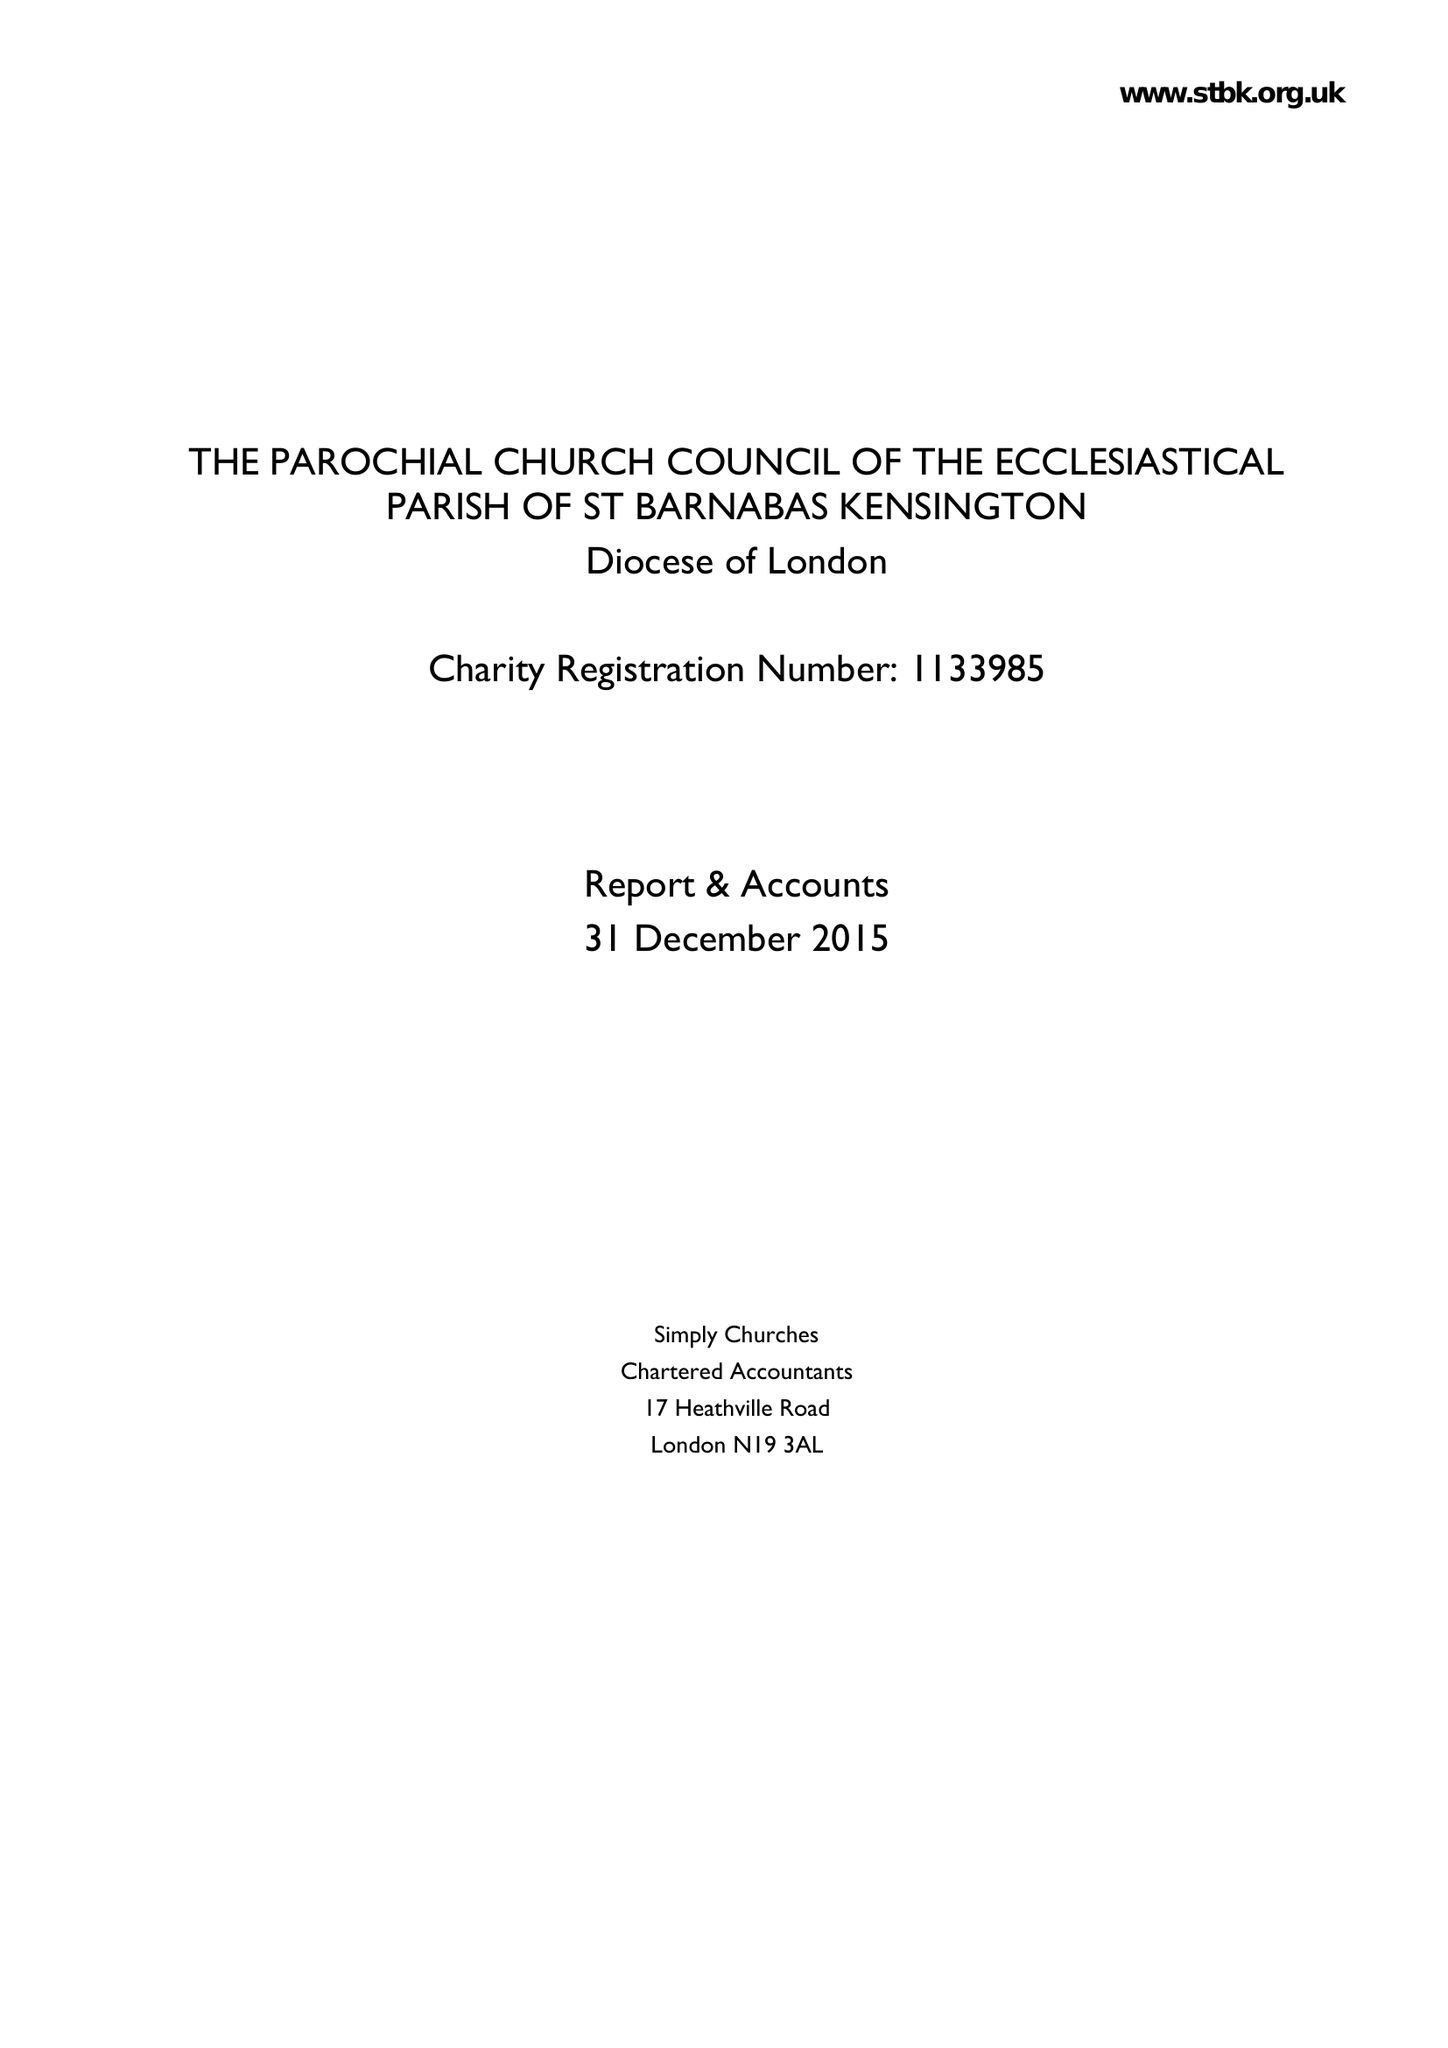What is the value for the charity_name?
Answer the question using a single word or phrase. The Parochial Church Council Of The Ecclesiastical Parish Of St Barnabas Kensington 